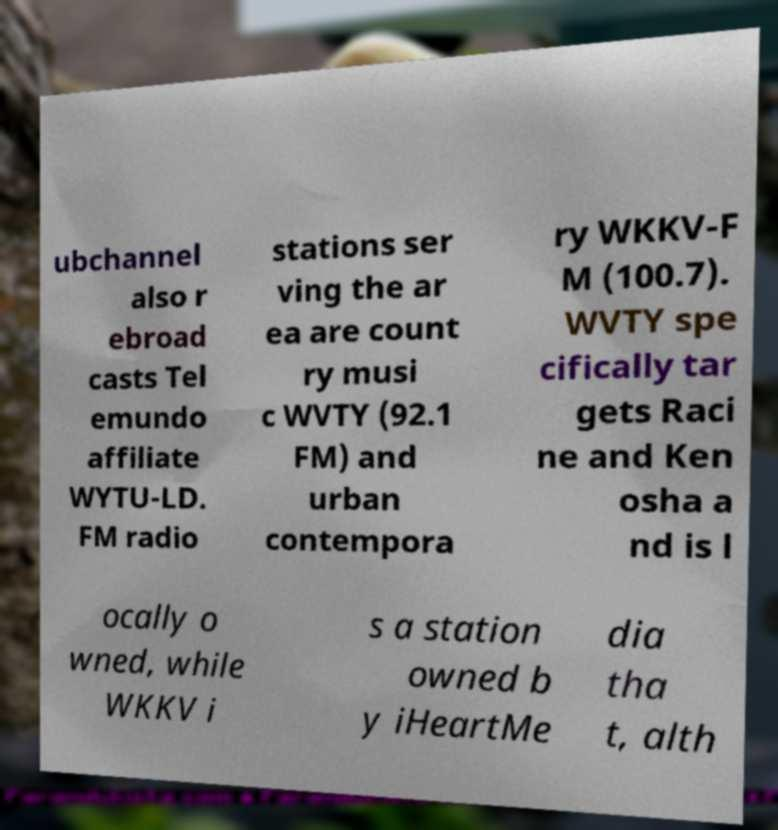Could you assist in decoding the text presented in this image and type it out clearly? ubchannel also r ebroad casts Tel emundo affiliate WYTU-LD. FM radio stations ser ving the ar ea are count ry musi c WVTY (92.1 FM) and urban contempora ry WKKV-F M (100.7). WVTY spe cifically tar gets Raci ne and Ken osha a nd is l ocally o wned, while WKKV i s a station owned b y iHeartMe dia tha t, alth 